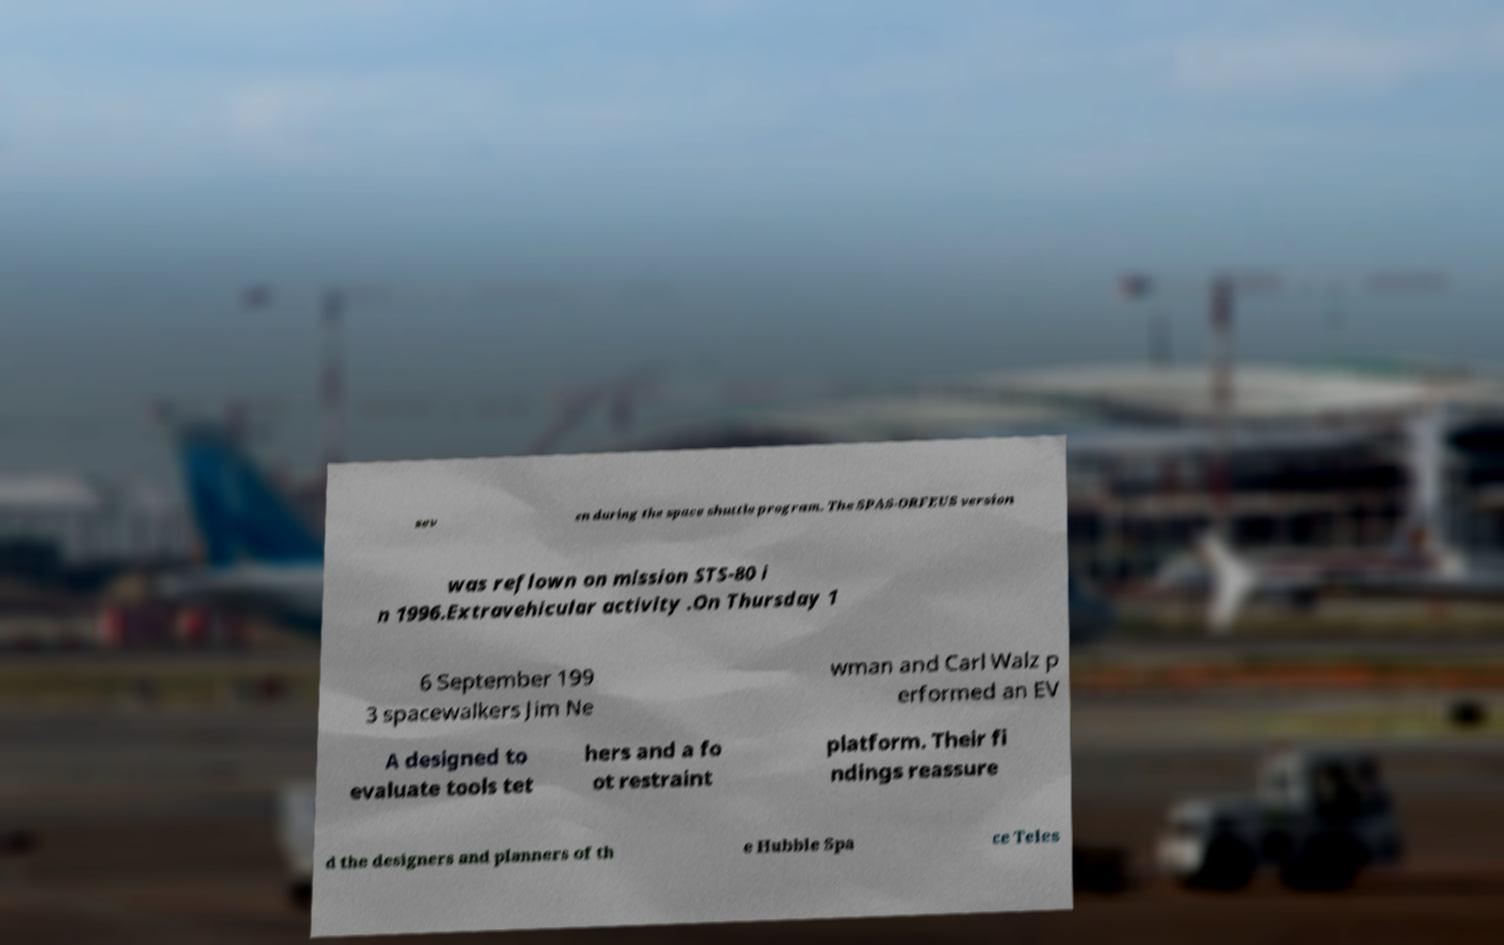What messages or text are displayed in this image? I need them in a readable, typed format. sev en during the space shuttle program. The SPAS-ORFEUS version was reflown on mission STS-80 i n 1996.Extravehicular activity .On Thursday 1 6 September 199 3 spacewalkers Jim Ne wman and Carl Walz p erformed an EV A designed to evaluate tools tet hers and a fo ot restraint platform. Their fi ndings reassure d the designers and planners of th e Hubble Spa ce Teles 